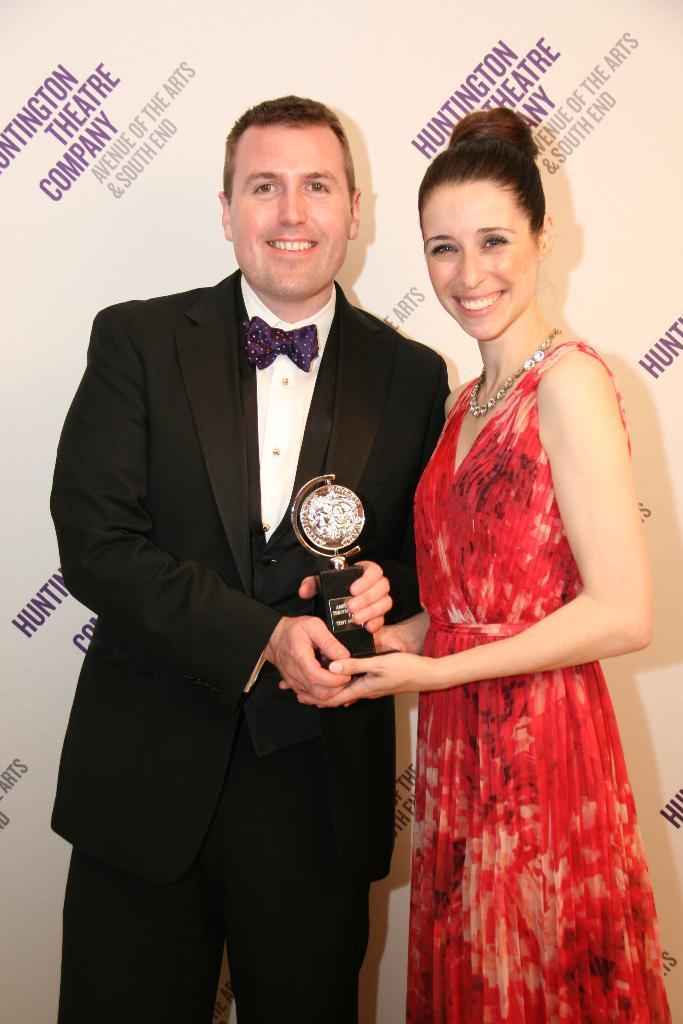Which theatre company is featured?
Your response must be concise. Huntington. What is the text written in gray?
Offer a terse response. Avenue of the arts & south end. 